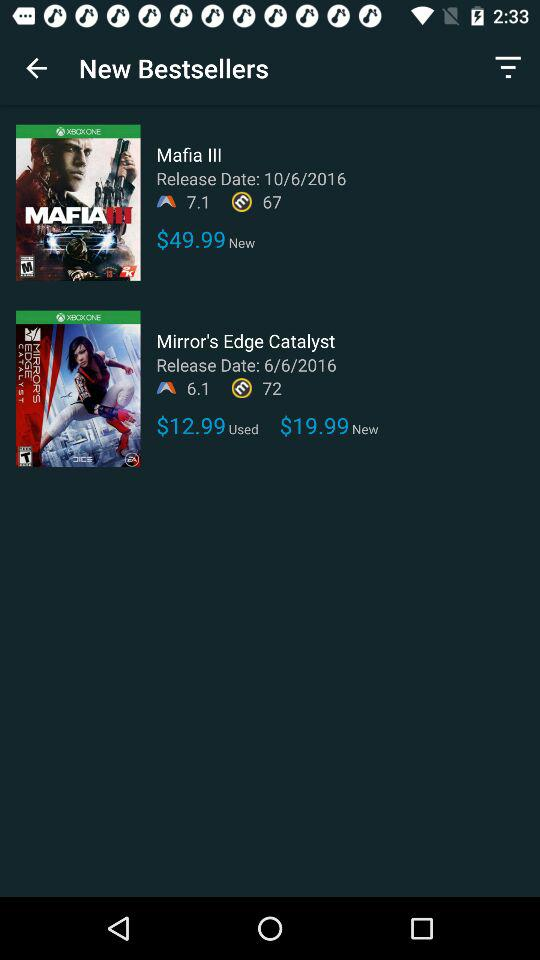What is the release date of "Mafia III"? The release date of "Mafia III" is October 6, 2016. 